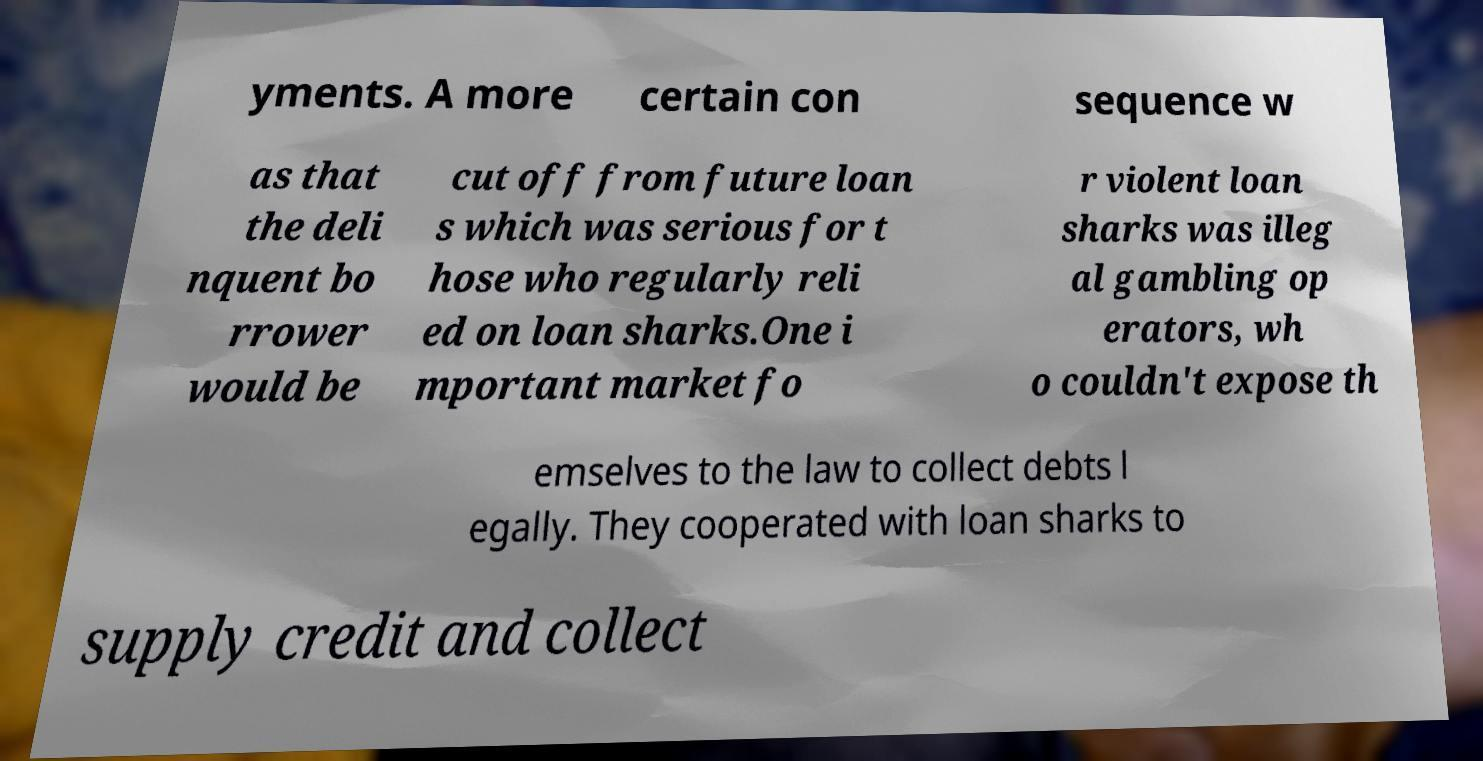Please identify and transcribe the text found in this image. yments. A more certain con sequence w as that the deli nquent bo rrower would be cut off from future loan s which was serious for t hose who regularly reli ed on loan sharks.One i mportant market fo r violent loan sharks was illeg al gambling op erators, wh o couldn't expose th emselves to the law to collect debts l egally. They cooperated with loan sharks to supply credit and collect 